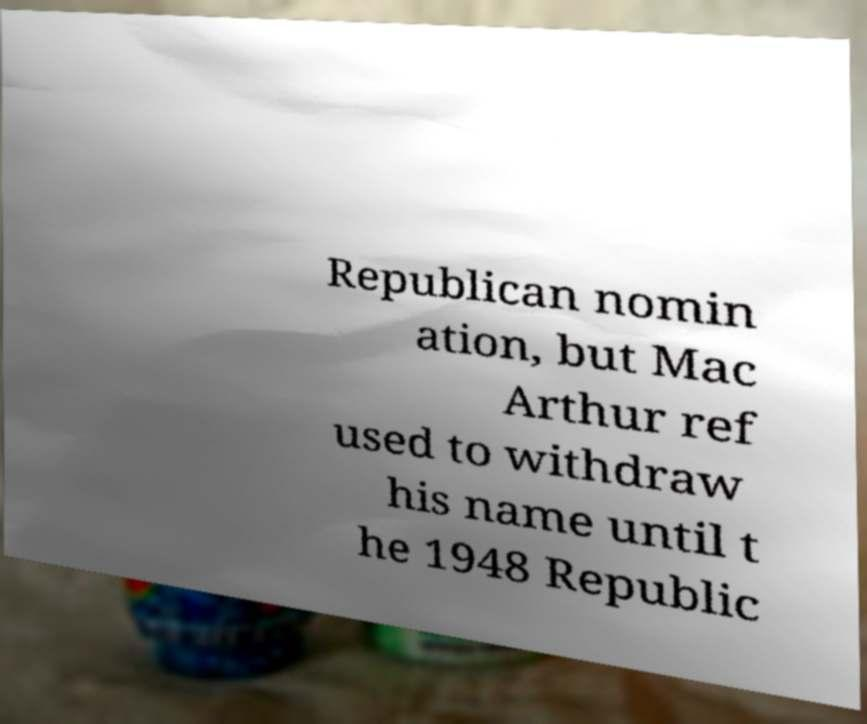For documentation purposes, I need the text within this image transcribed. Could you provide that? Republican nomin ation, but Mac Arthur ref used to withdraw his name until t he 1948 Republic 